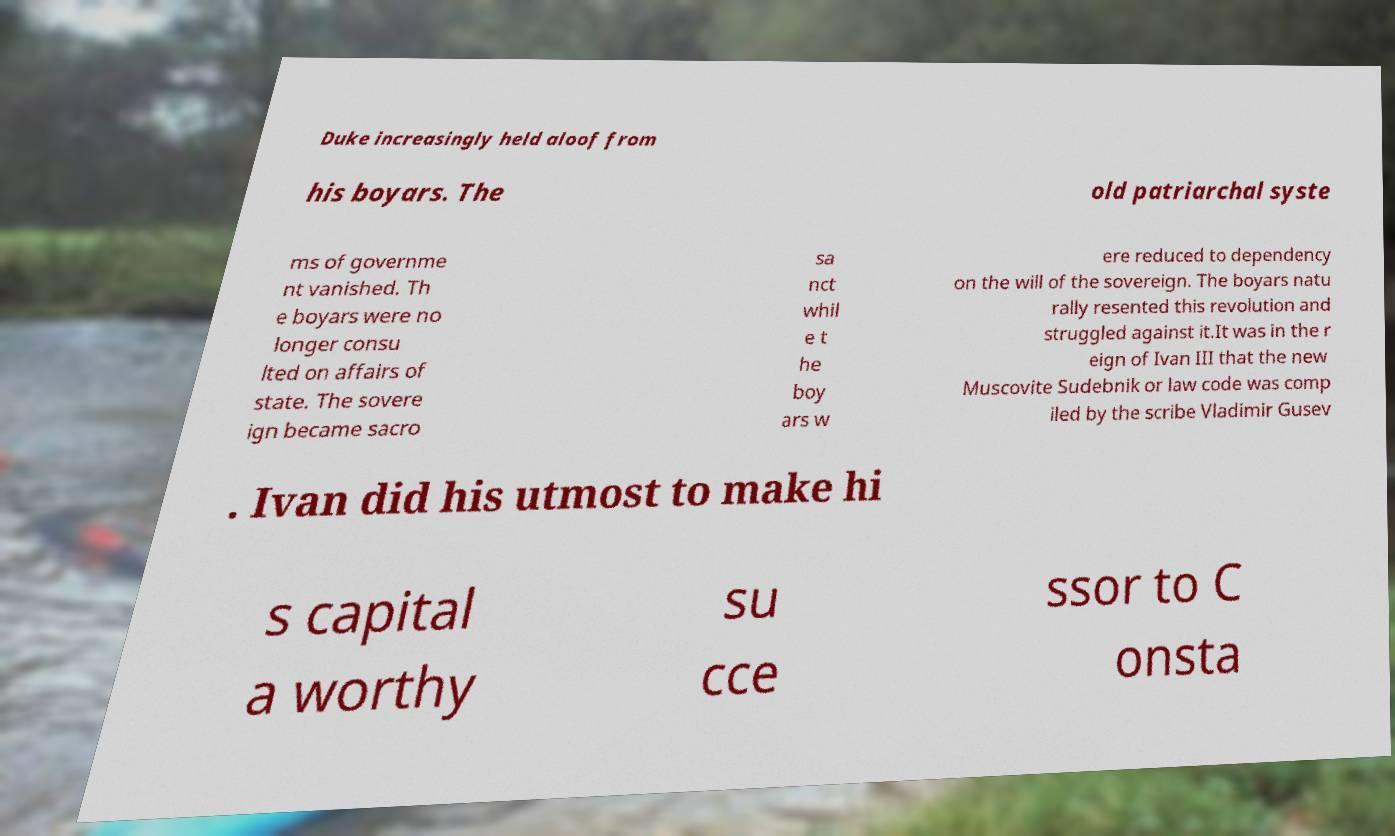Please read and relay the text visible in this image. What does it say? Duke increasingly held aloof from his boyars. The old patriarchal syste ms of governme nt vanished. Th e boyars were no longer consu lted on affairs of state. The sovere ign became sacro sa nct whil e t he boy ars w ere reduced to dependency on the will of the sovereign. The boyars natu rally resented this revolution and struggled against it.It was in the r eign of Ivan III that the new Muscovite Sudebnik or law code was comp iled by the scribe Vladimir Gusev . Ivan did his utmost to make hi s capital a worthy su cce ssor to C onsta 